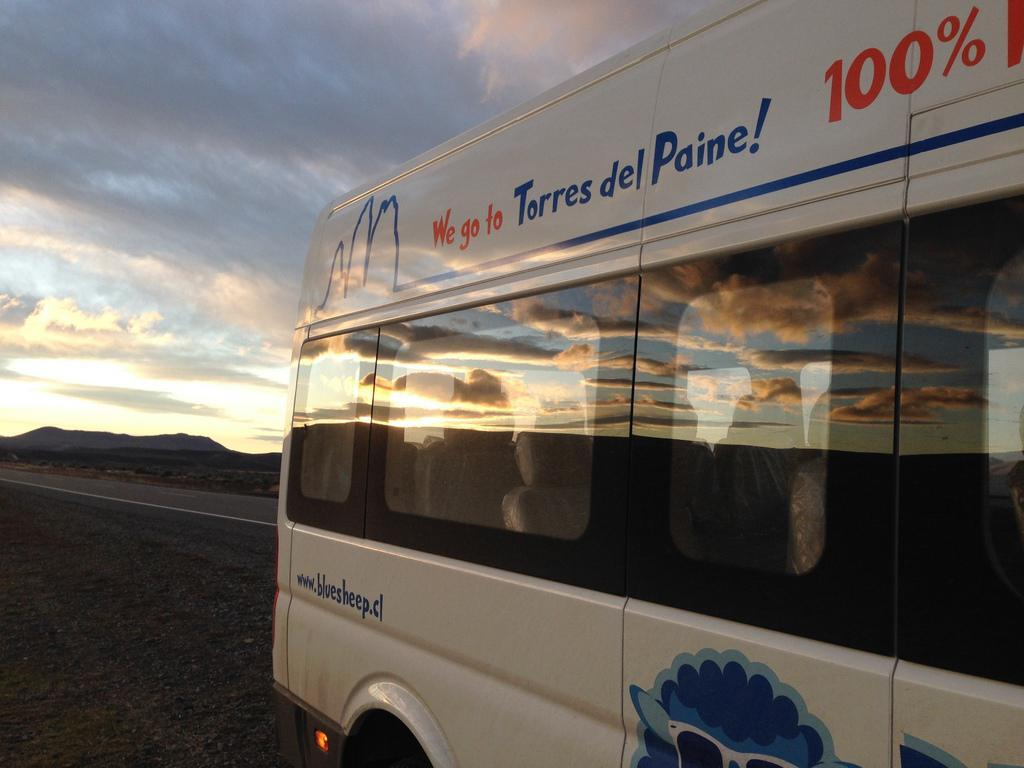What color is the vehicle in the image? The vehicle in the image is white-colored. What can be seen on the vehicle besides its color? There is writing on the vehicle. What can be seen in the background of the image? Clouds and the sky are visible in the background of the image. How many kittens are playing a game on the hood of the vehicle in the image? There are no kittens or games present in the image; it only features a white-colored vehicle with writing on it and a background of clouds and the sky. 